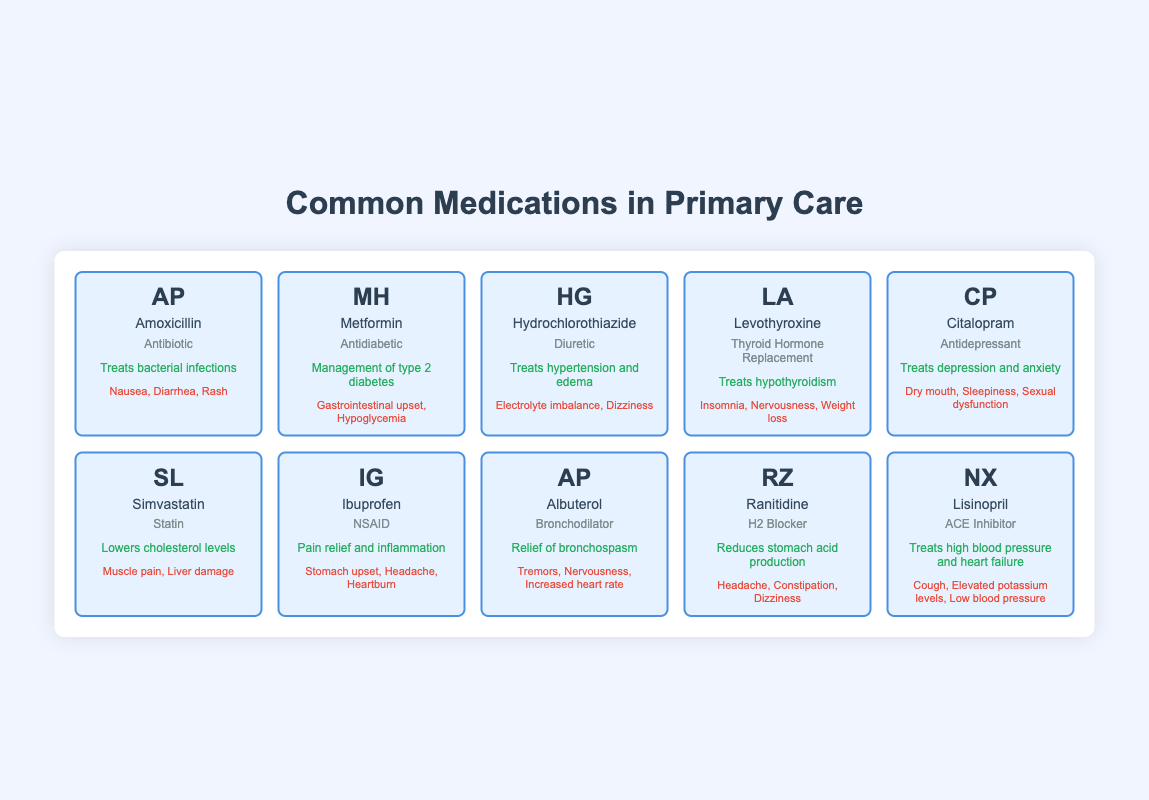What is the use of Amoxicillin? Amoxicillin is listed under the "uses" section as treating bacterial infections. This information can be directly retrieved from the table where Amoxicillin is described.
Answer: Treats bacterial infections Which medication has the common side effect of dizziness? The table shows that both Hydrochlorothiazide and Ranitidine list dizziness as a common side effect. Thus, the answer is found by examining the side effects of both medications.
Answer: Hydrochlorothiazide, Ranitidine How many medications are classified as antidepressants? Only Citalopram is indicated in the table as an antidepressant. By counting the number of entries under that category, the answer is determined.
Answer: 1 Is Levothyroxine an antidiabetic medication? According to the table, Levothyroxine is categorized under "Thyroid Hormone Replacement," indicating it is not an antidiabetic medication. This fact can be directly gleaned from the category listing.
Answer: No Which medication listed has the most common side effects? Simvastatin states "Muscle pain, Liver damage" as common side effects, only two items. When compared to others, medications like Citalopram and Albuterol list three. So, by ranking these, it's evident the highest belongs to Citalopram and Albuterol.
Answer: Citalopram, Albuterol If a patient is experiencing both gastrointestinal upset and hypoglycemia, which medication might they be taking? Metformin lists gastrointestinal upset and hypoglycemia as common side effects. To answer, one looks at the side effects under the medications and matches the conditions stated.
Answer: Metformin What is the difference in the number of side effects between Ibuprofen and Simvastatin? Ibuprofen has three side effects listed: Stomach upset, Headache, and Heartburn. Simvastatin has two: Muscle pain and Liver damage. The difference is 3 minus 2, resulting in one more side effect for Ibuprofen.
Answer: 1 How many medications are used to treat hypertension? The table contains Hydrochlorothiazide and Lisinopril, which are both categorized under medications for treating hypertension. Thus, counting these entries provides the answer to the question.
Answer: 2 Is Albuterol categorized as a statin? The table classifies Albuterol as a bronchodilator and not under the statin classification. To determine the answer, one must reference the table and the categorization explicitly provided.
Answer: No 